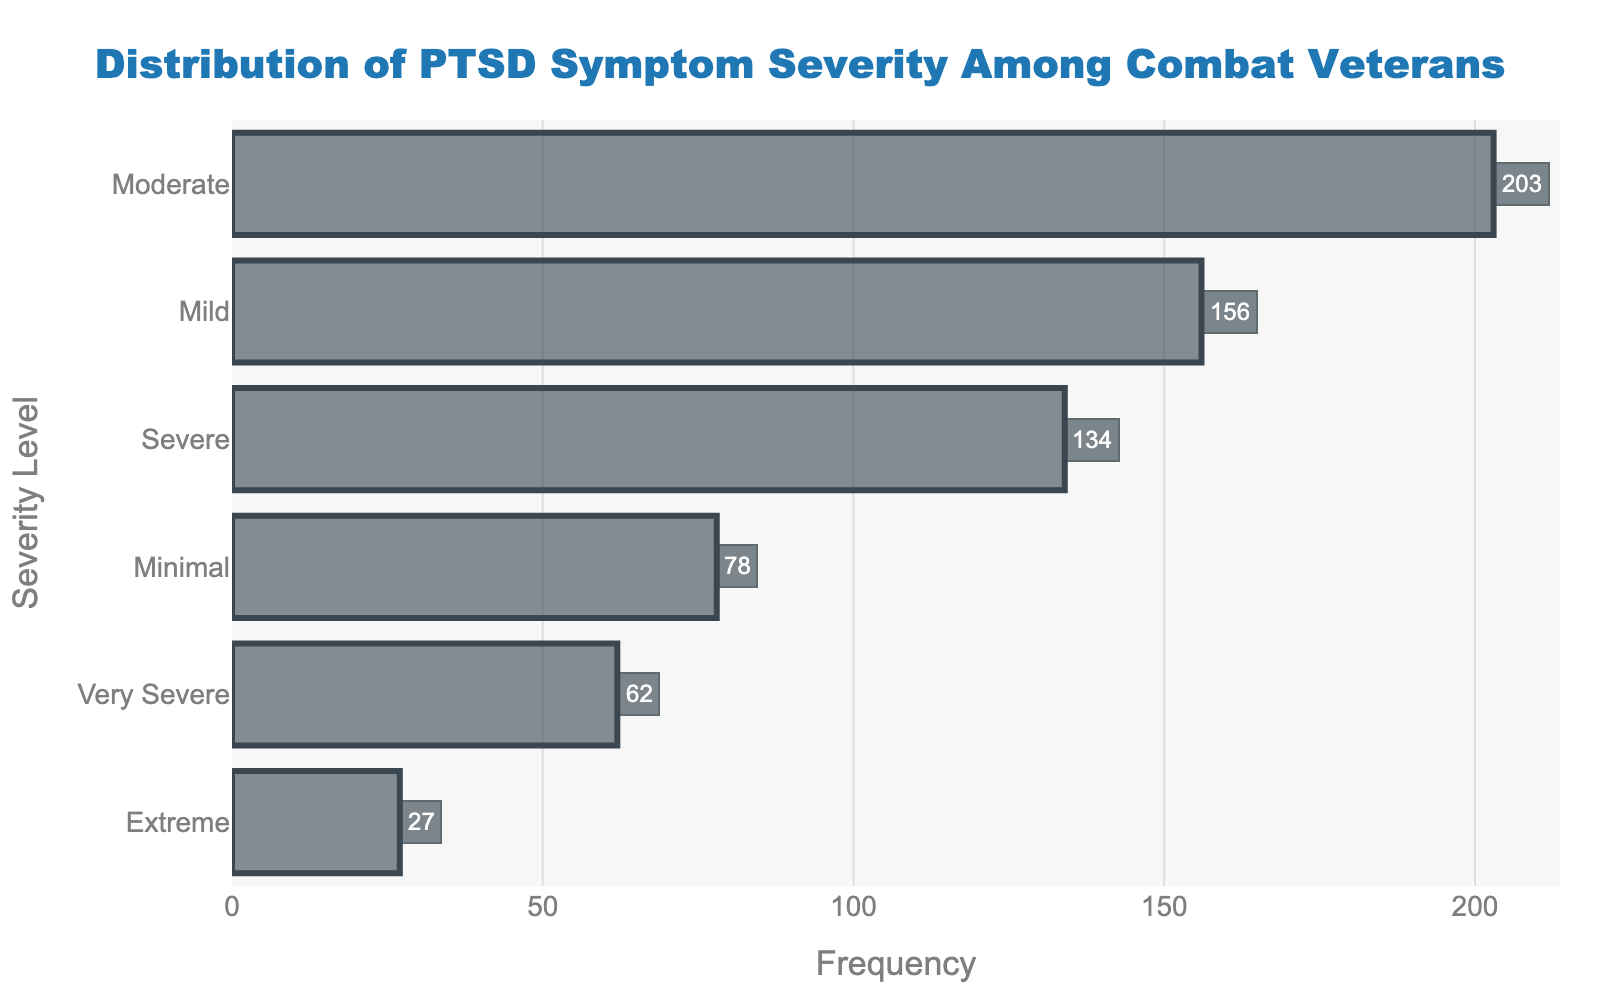What is the title of the figure? The title is prominently displayed at the top of the figure, centered and emphasized with a larger font size. The title reads "Distribution of PTSD Symptom Severity Among Combat Veterans".
Answer: "Distribution of PTSD Symptom Severity Among Combat Veterans" How many severity levels are present in the data? By counting the distinct labels present on the y-axis, we see there are six severity levels: Minimal, Mild, Moderate, Severe, Very Severe, and Extreme.
Answer: 6 Which severity level has the highest frequency? By examining the horizontal bars, the bar corresponding to the 'Moderate' severity level is the longest, thus indicating it has the highest frequency.
Answer: Moderate What is the frequency of the 'Extreme' severity level? The annotation at the end of the horizontal bar corresponding to 'Extreme' severity level shows the value 27.
Answer: 27 Which severity levels have frequencies higher than 100? By checking the annotated frequency values, 'Mild' (156), 'Moderate' (203), and 'Severe' (134) all have frequencies higher than 100.
Answer: Mild, Moderate, Severe What is the average frequency of all severity levels? To find the average frequency, sum all frequencies and divide by the number of severity levels: (78 + 156 + 203 + 134 + 62 + 27) / 6 = 660 / 6 = 110.
Answer: 110 Compare the frequency of 'Minimal' and 'Very Severe' severity levels. Which one is higher? The figure shows 'Minimal' has a frequency of 78, and 'Very Severe' has a frequency of 62. Since 78 is greater than 62, the 'Minimal' severity level has a higher frequency.
Answer: Minimal How much more frequent is 'Moderate' severity compared to 'Extreme' severity? Subtract the frequency of 'Extreme' from 'Moderate': 203 - 27 = 176.
Answer: 176 What is the total frequency for both 'Severe' and 'Very Severe' severity levels combined? Add the frequencies of 'Severe' and 'Very Severe': 134 + 62 = 196.
Answer: 196 Is the frequency of 'Mild' severity greater or less than twice the frequency of 'Minimal' severity? Calculate twice the frequency of 'Minimal': 2 * 78 = 156. Since 'Mild' has a frequency of 156, it is equal to twice the frequency of 'Minimal' severity.
Answer: Equal 